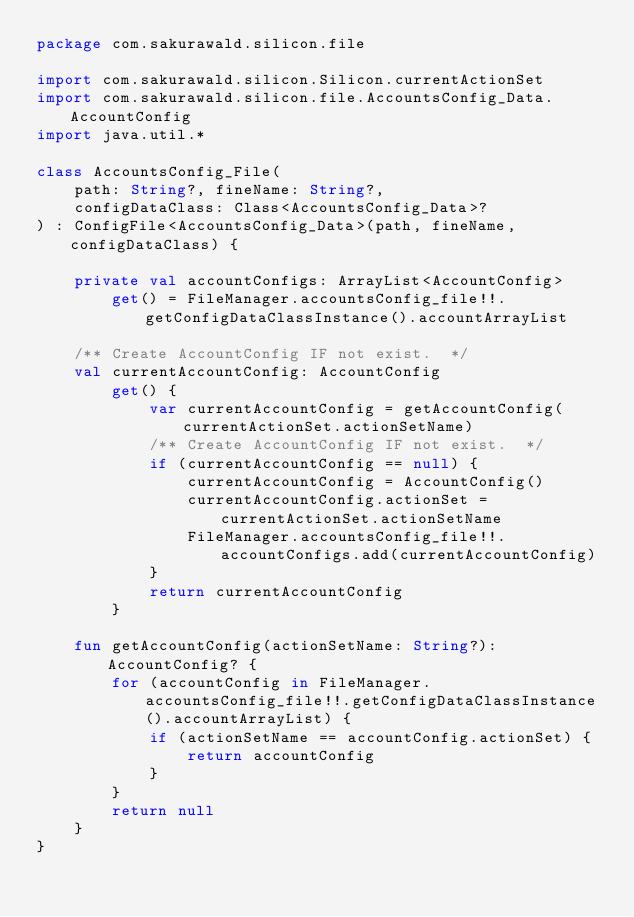Convert code to text. <code><loc_0><loc_0><loc_500><loc_500><_Kotlin_>package com.sakurawald.silicon.file

import com.sakurawald.silicon.Silicon.currentActionSet
import com.sakurawald.silicon.file.AccountsConfig_Data.AccountConfig
import java.util.*

class AccountsConfig_File(
    path: String?, fineName: String?,
    configDataClass: Class<AccountsConfig_Data>?
) : ConfigFile<AccountsConfig_Data>(path, fineName, configDataClass) {

    private val accountConfigs: ArrayList<AccountConfig>
        get() = FileManager.accountsConfig_file!!.getConfigDataClassInstance().accountArrayList

    /** Create AccountConfig IF not exist.  */
    val currentAccountConfig: AccountConfig
        get() {
            var currentAccountConfig = getAccountConfig(currentActionSet.actionSetName)
            /** Create AccountConfig IF not exist.  */
            if (currentAccountConfig == null) {
                currentAccountConfig = AccountConfig()
                currentAccountConfig.actionSet = currentActionSet.actionSetName
                FileManager.accountsConfig_file!!.accountConfigs.add(currentAccountConfig)
            }
            return currentAccountConfig
        }

    fun getAccountConfig(actionSetName: String?): AccountConfig? {
        for (accountConfig in FileManager.accountsConfig_file!!.getConfigDataClassInstance().accountArrayList) {
            if (actionSetName == accountConfig.actionSet) {
                return accountConfig
            }
        }
        return null
    }
}</code> 